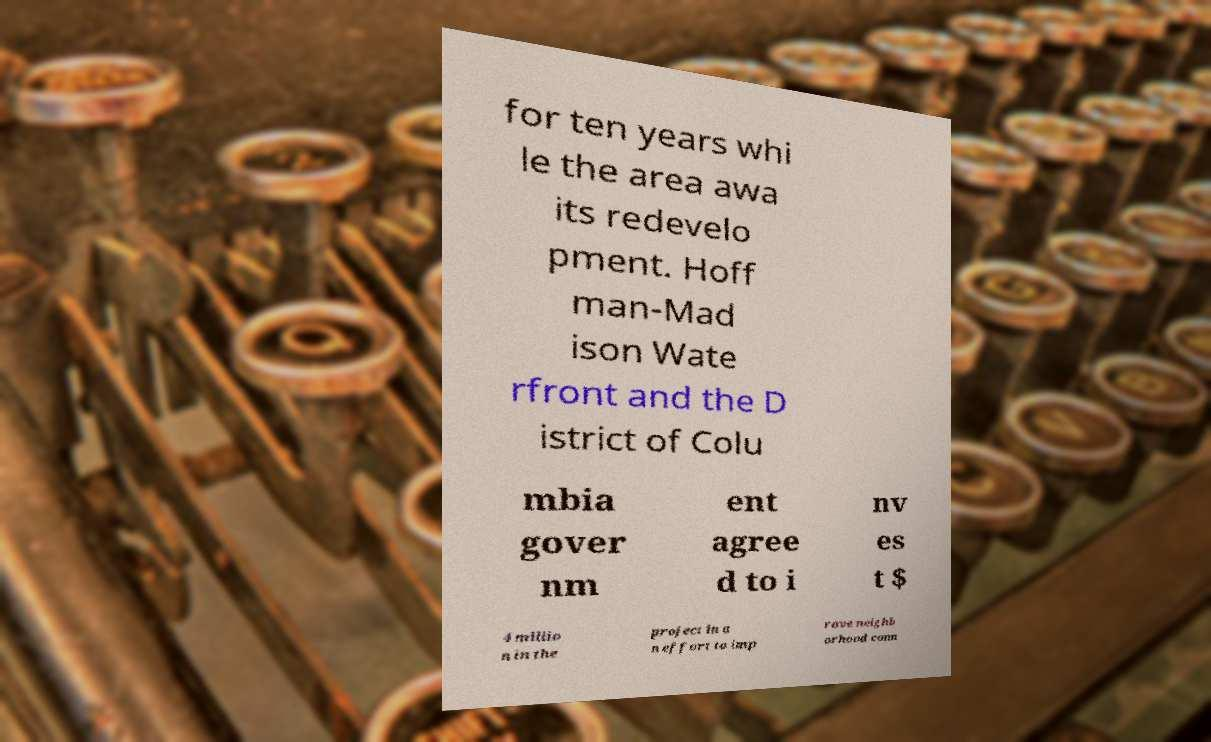Can you accurately transcribe the text from the provided image for me? for ten years whi le the area awa its redevelo pment. Hoff man-Mad ison Wate rfront and the D istrict of Colu mbia gover nm ent agree d to i nv es t $ 4 millio n in the project in a n effort to imp rove neighb orhood conn 